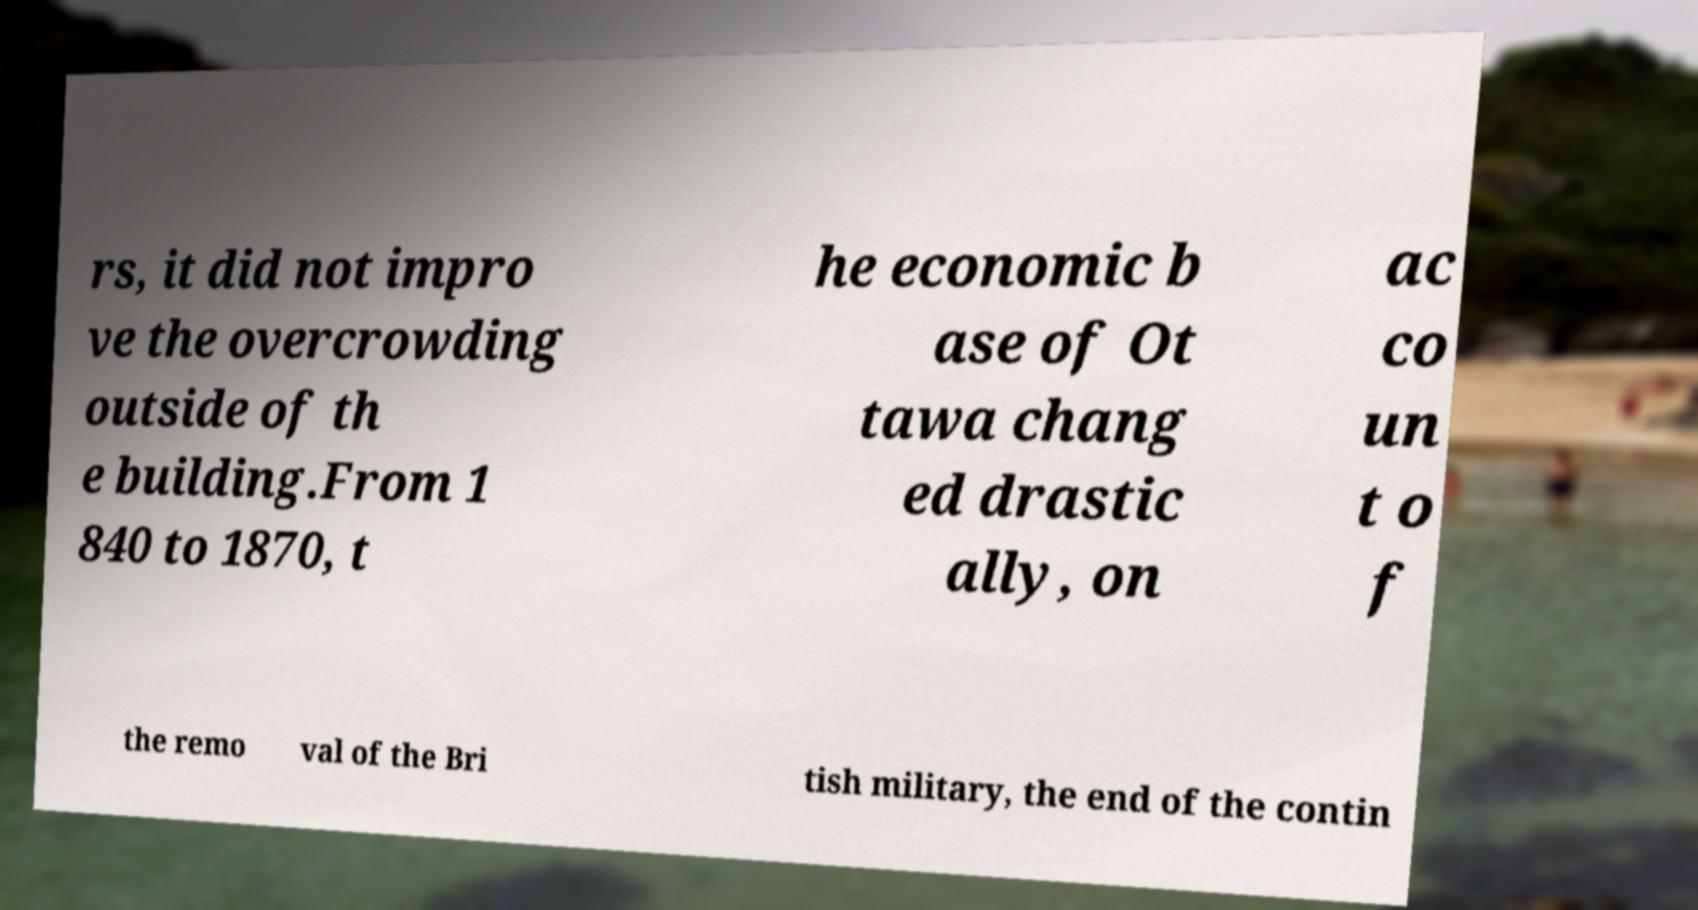Could you assist in decoding the text presented in this image and type it out clearly? rs, it did not impro ve the overcrowding outside of th e building.From 1 840 to 1870, t he economic b ase of Ot tawa chang ed drastic ally, on ac co un t o f the remo val of the Bri tish military, the end of the contin 